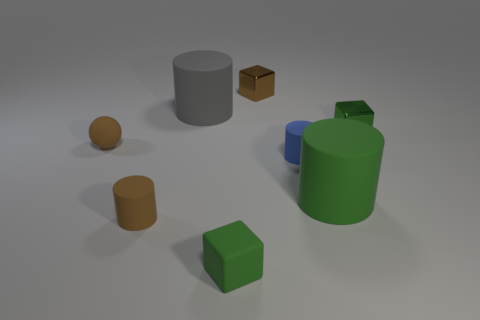Subtract 1 cylinders. How many cylinders are left? 3 Add 2 blue matte balls. How many objects exist? 10 Subtract all balls. How many objects are left? 7 Subtract 1 green cylinders. How many objects are left? 7 Subtract all tiny matte blocks. Subtract all rubber cubes. How many objects are left? 6 Add 1 green objects. How many green objects are left? 4 Add 4 green shiny things. How many green shiny things exist? 5 